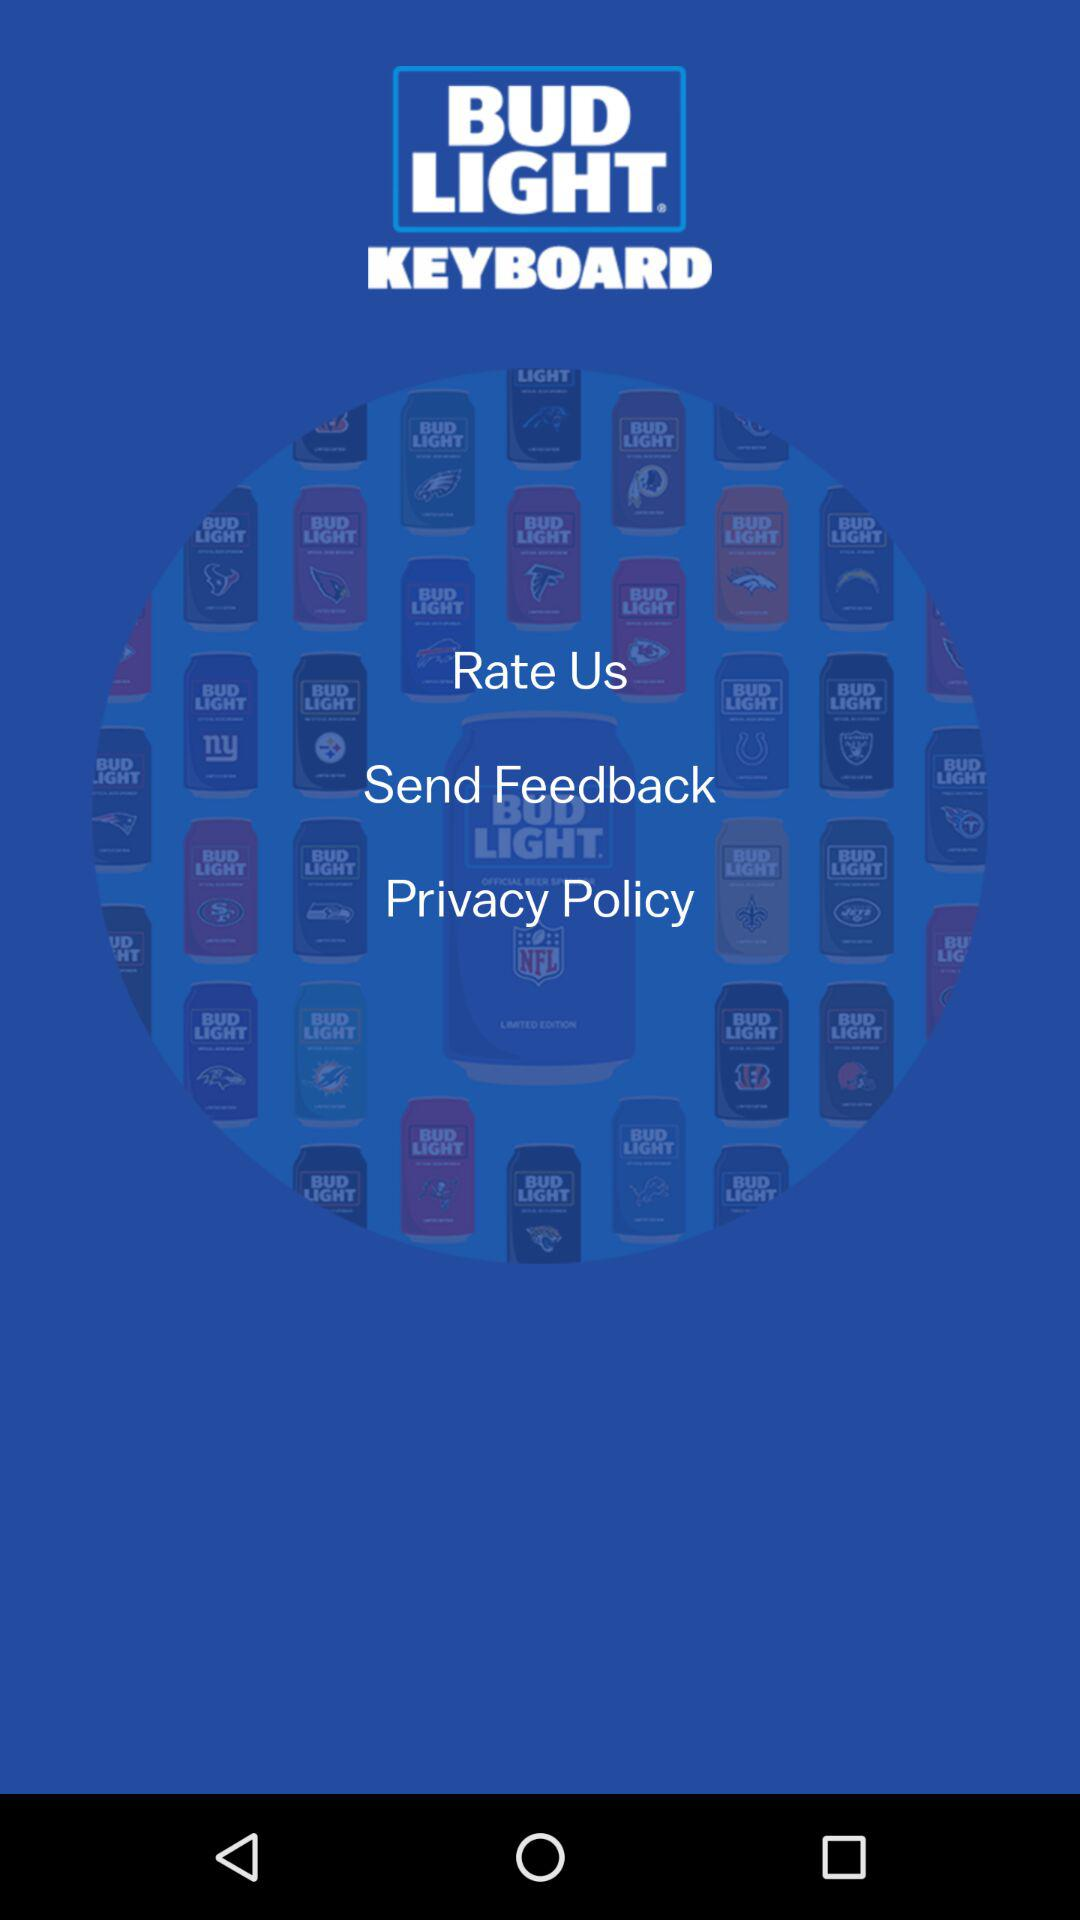What is the name of the application? The name of the application is "BUD LIGHT KEYBOARD". 